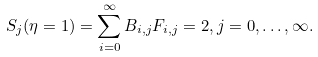Convert formula to latex. <formula><loc_0><loc_0><loc_500><loc_500>S _ { j } ( \eta = 1 ) = \sum _ { i = 0 } ^ { \infty } B _ { i , j } F _ { i , j } = 2 , j = 0 , \dots , \infty .</formula> 